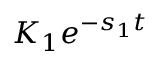Convert formula to latex. <formula><loc_0><loc_0><loc_500><loc_500>K _ { 1 } e ^ { - s _ { 1 } t }</formula> 